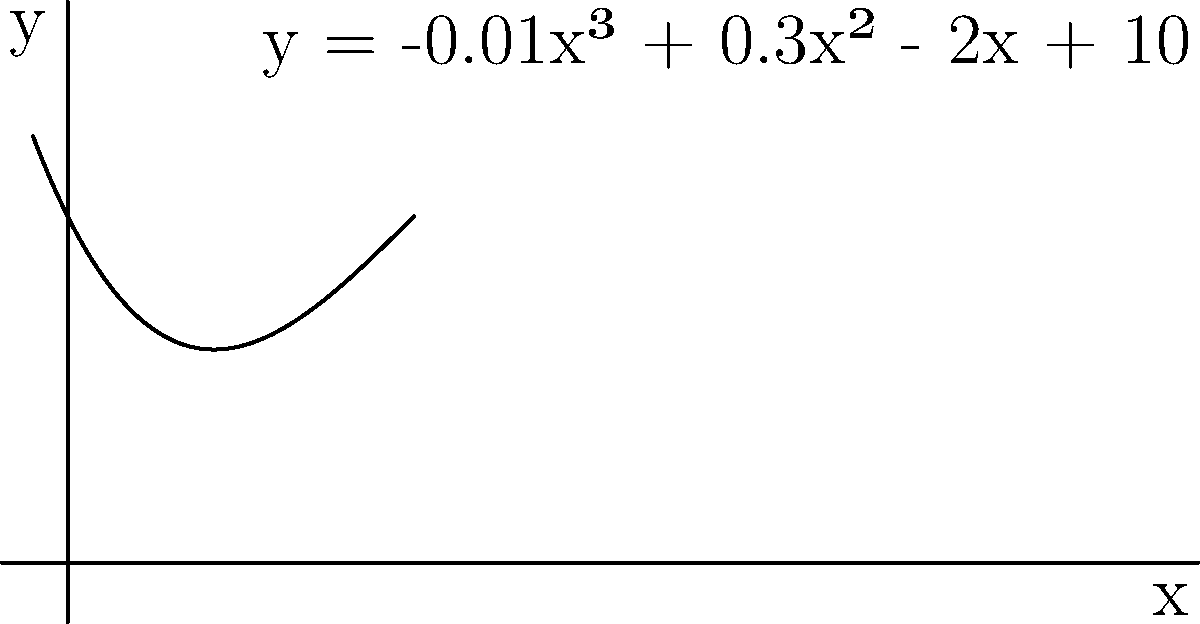The population of the endangered Kākāpō, a flightless parrot native to New Zealand, can be modeled by the polynomial function $y = -0.01x^3 + 0.3x^2 - 2x + 10$, where $y$ represents the population in hundreds and $x$ represents the number of years since conservation efforts began. Find the number of years it will take for the Kākāpō population to become extinct (i.e., reach zero) according to this model. To find when the population becomes extinct, we need to find the positive root of the equation:

$$-0.01x^3 + 0.3x^2 - 2x + 10 = 0$$

Let's solve this step-by-step:

1) First, we can factor out the greatest common factor:
   $$-0.01(x^3 - 30x^2 + 200x - 1000) = 0$$

2) The polynomial inside the parentheses can be solved using the rational root theorem. The possible rational roots are the factors of 1000: ±1, ±2, ±4, ±5, ±8, ±10, ±20, ±25, ±40, ±50, ±100, ±125, ±200, ±250, ±500, ±1000.

3) Testing these values, we find that x = 10 is a root.

4) Dividing the polynomial by (x - 10), we get:
   $$-0.01(x^2 - 20x + 100) = 0$$

5) This quadratic can be solved using the quadratic formula:
   $$x = \frac{-b \pm \sqrt{b^2 - 4ac}}{2a}$$
   where $a = 1$, $b = -20$, and $c = 100$

6) Solving this:
   $$x = \frac{20 \pm \sqrt{400 - 400}}{2} = \frac{20 \pm 0}{2} = 10$$

7) Therefore, the roots are 10, 10, and 10.

The positive root 10 represents the number of years it will take for the population to become extinct.
Answer: 10 years 